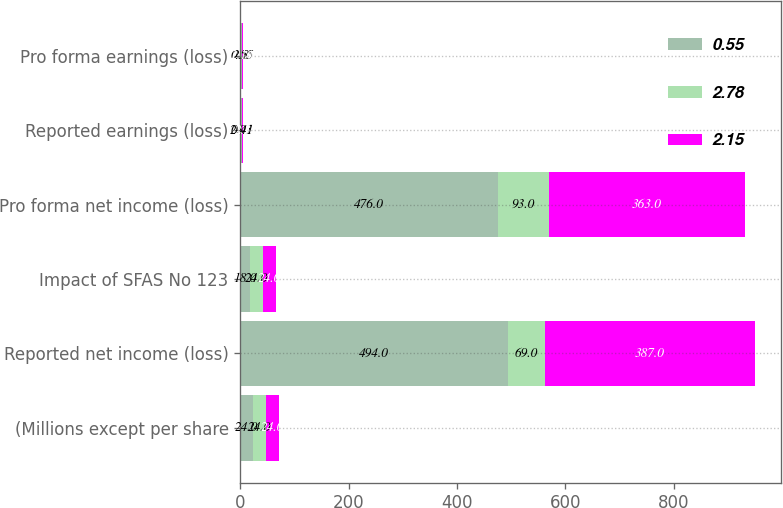Convert chart. <chart><loc_0><loc_0><loc_500><loc_500><stacked_bar_chart><ecel><fcel>(Millions except per share<fcel>Reported net income (loss)<fcel>Impact of SFAS No 123<fcel>Pro forma net income (loss)<fcel>Reported earnings (loss)<fcel>Pro forma earnings (loss)<nl><fcel>0.55<fcel>24<fcel>494<fcel>18<fcel>476<fcel>2.91<fcel>2.8<nl><fcel>2.78<fcel>24<fcel>69<fcel>24<fcel>93<fcel>0.41<fcel>0.55<nl><fcel>2.15<fcel>24<fcel>387<fcel>24<fcel>363<fcel>2.3<fcel>2.16<nl></chart> 